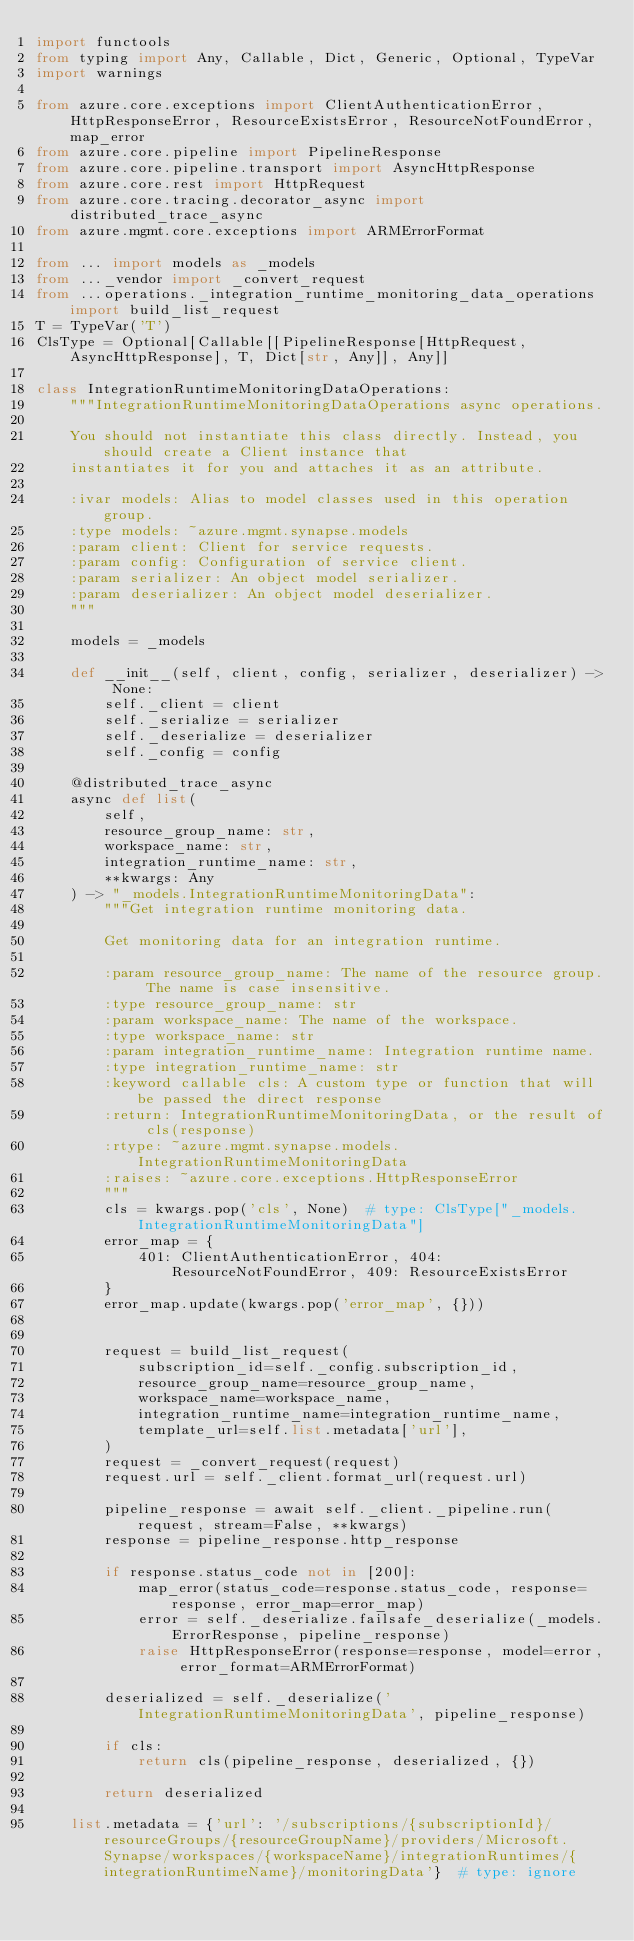<code> <loc_0><loc_0><loc_500><loc_500><_Python_>import functools
from typing import Any, Callable, Dict, Generic, Optional, TypeVar
import warnings

from azure.core.exceptions import ClientAuthenticationError, HttpResponseError, ResourceExistsError, ResourceNotFoundError, map_error
from azure.core.pipeline import PipelineResponse
from azure.core.pipeline.transport import AsyncHttpResponse
from azure.core.rest import HttpRequest
from azure.core.tracing.decorator_async import distributed_trace_async
from azure.mgmt.core.exceptions import ARMErrorFormat

from ... import models as _models
from ..._vendor import _convert_request
from ...operations._integration_runtime_monitoring_data_operations import build_list_request
T = TypeVar('T')
ClsType = Optional[Callable[[PipelineResponse[HttpRequest, AsyncHttpResponse], T, Dict[str, Any]], Any]]

class IntegrationRuntimeMonitoringDataOperations:
    """IntegrationRuntimeMonitoringDataOperations async operations.

    You should not instantiate this class directly. Instead, you should create a Client instance that
    instantiates it for you and attaches it as an attribute.

    :ivar models: Alias to model classes used in this operation group.
    :type models: ~azure.mgmt.synapse.models
    :param client: Client for service requests.
    :param config: Configuration of service client.
    :param serializer: An object model serializer.
    :param deserializer: An object model deserializer.
    """

    models = _models

    def __init__(self, client, config, serializer, deserializer) -> None:
        self._client = client
        self._serialize = serializer
        self._deserialize = deserializer
        self._config = config

    @distributed_trace_async
    async def list(
        self,
        resource_group_name: str,
        workspace_name: str,
        integration_runtime_name: str,
        **kwargs: Any
    ) -> "_models.IntegrationRuntimeMonitoringData":
        """Get integration runtime monitoring data.

        Get monitoring data for an integration runtime.

        :param resource_group_name: The name of the resource group. The name is case insensitive.
        :type resource_group_name: str
        :param workspace_name: The name of the workspace.
        :type workspace_name: str
        :param integration_runtime_name: Integration runtime name.
        :type integration_runtime_name: str
        :keyword callable cls: A custom type or function that will be passed the direct response
        :return: IntegrationRuntimeMonitoringData, or the result of cls(response)
        :rtype: ~azure.mgmt.synapse.models.IntegrationRuntimeMonitoringData
        :raises: ~azure.core.exceptions.HttpResponseError
        """
        cls = kwargs.pop('cls', None)  # type: ClsType["_models.IntegrationRuntimeMonitoringData"]
        error_map = {
            401: ClientAuthenticationError, 404: ResourceNotFoundError, 409: ResourceExistsError
        }
        error_map.update(kwargs.pop('error_map', {}))

        
        request = build_list_request(
            subscription_id=self._config.subscription_id,
            resource_group_name=resource_group_name,
            workspace_name=workspace_name,
            integration_runtime_name=integration_runtime_name,
            template_url=self.list.metadata['url'],
        )
        request = _convert_request(request)
        request.url = self._client.format_url(request.url)

        pipeline_response = await self._client._pipeline.run(request, stream=False, **kwargs)
        response = pipeline_response.http_response

        if response.status_code not in [200]:
            map_error(status_code=response.status_code, response=response, error_map=error_map)
            error = self._deserialize.failsafe_deserialize(_models.ErrorResponse, pipeline_response)
            raise HttpResponseError(response=response, model=error, error_format=ARMErrorFormat)

        deserialized = self._deserialize('IntegrationRuntimeMonitoringData', pipeline_response)

        if cls:
            return cls(pipeline_response, deserialized, {})

        return deserialized

    list.metadata = {'url': '/subscriptions/{subscriptionId}/resourceGroups/{resourceGroupName}/providers/Microsoft.Synapse/workspaces/{workspaceName}/integrationRuntimes/{integrationRuntimeName}/monitoringData'}  # type: ignore

</code> 